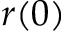Convert formula to latex. <formula><loc_0><loc_0><loc_500><loc_500>r ( 0 )</formula> 